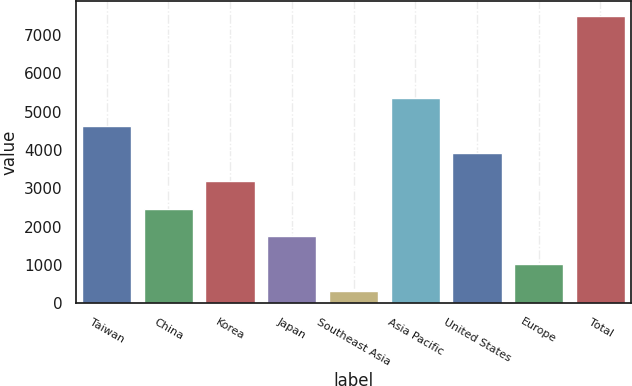Convert chart. <chart><loc_0><loc_0><loc_500><loc_500><bar_chart><fcel>Taiwan<fcel>China<fcel>Korea<fcel>Japan<fcel>Southeast Asia<fcel>Asia Pacific<fcel>United States<fcel>Europe<fcel>Total<nl><fcel>4633.4<fcel>2476.7<fcel>3195.6<fcel>1757.8<fcel>320<fcel>5356<fcel>3914.5<fcel>1038.9<fcel>7509<nl></chart> 